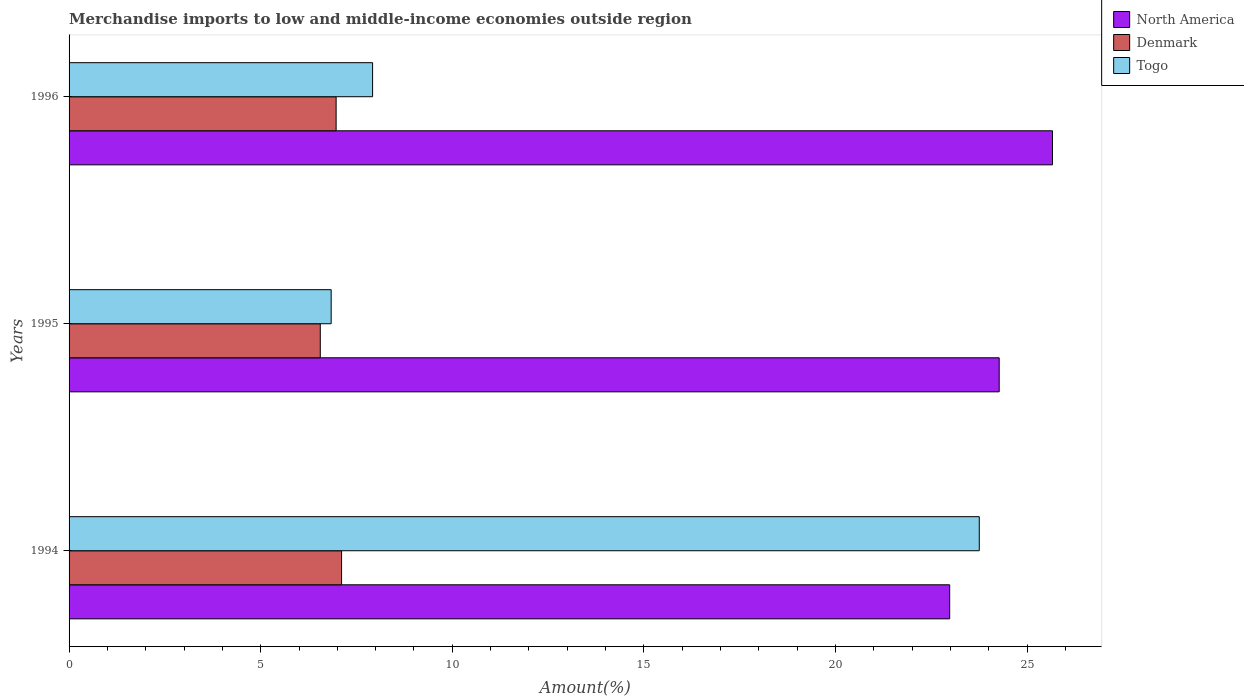How many groups of bars are there?
Your answer should be compact. 3. Are the number of bars per tick equal to the number of legend labels?
Offer a very short reply. Yes. Are the number of bars on each tick of the Y-axis equal?
Offer a terse response. Yes. How many bars are there on the 2nd tick from the bottom?
Provide a short and direct response. 3. In how many cases, is the number of bars for a given year not equal to the number of legend labels?
Keep it short and to the point. 0. What is the percentage of amount earned from merchandise imports in Denmark in 1996?
Your answer should be compact. 6.97. Across all years, what is the maximum percentage of amount earned from merchandise imports in North America?
Offer a very short reply. 25.66. Across all years, what is the minimum percentage of amount earned from merchandise imports in North America?
Give a very brief answer. 22.98. In which year was the percentage of amount earned from merchandise imports in Togo maximum?
Make the answer very short. 1994. In which year was the percentage of amount earned from merchandise imports in North America minimum?
Ensure brevity in your answer.  1994. What is the total percentage of amount earned from merchandise imports in North America in the graph?
Your answer should be very brief. 72.91. What is the difference between the percentage of amount earned from merchandise imports in Togo in 1994 and that in 1996?
Offer a very short reply. 15.83. What is the difference between the percentage of amount earned from merchandise imports in Togo in 1994 and the percentage of amount earned from merchandise imports in North America in 1995?
Ensure brevity in your answer.  -0.52. What is the average percentage of amount earned from merchandise imports in North America per year?
Offer a terse response. 24.3. In the year 1994, what is the difference between the percentage of amount earned from merchandise imports in Denmark and percentage of amount earned from merchandise imports in North America?
Provide a succinct answer. -15.87. What is the ratio of the percentage of amount earned from merchandise imports in Denmark in 1994 to that in 1995?
Give a very brief answer. 1.08. Is the difference between the percentage of amount earned from merchandise imports in Denmark in 1994 and 1996 greater than the difference between the percentage of amount earned from merchandise imports in North America in 1994 and 1996?
Offer a very short reply. Yes. What is the difference between the highest and the second highest percentage of amount earned from merchandise imports in Denmark?
Offer a terse response. 0.14. What is the difference between the highest and the lowest percentage of amount earned from merchandise imports in Togo?
Offer a very short reply. 16.91. What does the 2nd bar from the bottom in 1995 represents?
Give a very brief answer. Denmark. Are all the bars in the graph horizontal?
Your response must be concise. Yes. Are the values on the major ticks of X-axis written in scientific E-notation?
Ensure brevity in your answer.  No. Does the graph contain grids?
Ensure brevity in your answer.  No. How are the legend labels stacked?
Provide a short and direct response. Vertical. What is the title of the graph?
Keep it short and to the point. Merchandise imports to low and middle-income economies outside region. What is the label or title of the X-axis?
Offer a terse response. Amount(%). What is the label or title of the Y-axis?
Keep it short and to the point. Years. What is the Amount(%) in North America in 1994?
Make the answer very short. 22.98. What is the Amount(%) in Denmark in 1994?
Your answer should be very brief. 7.11. What is the Amount(%) in Togo in 1994?
Make the answer very short. 23.75. What is the Amount(%) in North America in 1995?
Offer a terse response. 24.27. What is the Amount(%) of Denmark in 1995?
Provide a short and direct response. 6.56. What is the Amount(%) of Togo in 1995?
Your answer should be compact. 6.84. What is the Amount(%) of North America in 1996?
Offer a terse response. 25.66. What is the Amount(%) of Denmark in 1996?
Offer a very short reply. 6.97. What is the Amount(%) of Togo in 1996?
Give a very brief answer. 7.92. Across all years, what is the maximum Amount(%) in North America?
Your answer should be compact. 25.66. Across all years, what is the maximum Amount(%) in Denmark?
Offer a very short reply. 7.11. Across all years, what is the maximum Amount(%) of Togo?
Provide a short and direct response. 23.75. Across all years, what is the minimum Amount(%) in North America?
Make the answer very short. 22.98. Across all years, what is the minimum Amount(%) of Denmark?
Offer a very short reply. 6.56. Across all years, what is the minimum Amount(%) of Togo?
Your answer should be compact. 6.84. What is the total Amount(%) in North America in the graph?
Keep it short and to the point. 72.91. What is the total Amount(%) in Denmark in the graph?
Give a very brief answer. 20.63. What is the total Amount(%) in Togo in the graph?
Offer a terse response. 38.51. What is the difference between the Amount(%) in North America in 1994 and that in 1995?
Ensure brevity in your answer.  -1.29. What is the difference between the Amount(%) of Denmark in 1994 and that in 1995?
Make the answer very short. 0.56. What is the difference between the Amount(%) of Togo in 1994 and that in 1995?
Give a very brief answer. 16.91. What is the difference between the Amount(%) of North America in 1994 and that in 1996?
Your answer should be very brief. -2.68. What is the difference between the Amount(%) in Denmark in 1994 and that in 1996?
Keep it short and to the point. 0.14. What is the difference between the Amount(%) of Togo in 1994 and that in 1996?
Provide a succinct answer. 15.83. What is the difference between the Amount(%) of North America in 1995 and that in 1996?
Your answer should be very brief. -1.39. What is the difference between the Amount(%) of Denmark in 1995 and that in 1996?
Your answer should be compact. -0.41. What is the difference between the Amount(%) of Togo in 1995 and that in 1996?
Your answer should be compact. -1.08. What is the difference between the Amount(%) in North America in 1994 and the Amount(%) in Denmark in 1995?
Ensure brevity in your answer.  16.42. What is the difference between the Amount(%) in North America in 1994 and the Amount(%) in Togo in 1995?
Make the answer very short. 16.14. What is the difference between the Amount(%) in Denmark in 1994 and the Amount(%) in Togo in 1995?
Your answer should be compact. 0.27. What is the difference between the Amount(%) in North America in 1994 and the Amount(%) in Denmark in 1996?
Keep it short and to the point. 16.01. What is the difference between the Amount(%) of North America in 1994 and the Amount(%) of Togo in 1996?
Offer a very short reply. 15.06. What is the difference between the Amount(%) of Denmark in 1994 and the Amount(%) of Togo in 1996?
Your response must be concise. -0.81. What is the difference between the Amount(%) in North America in 1995 and the Amount(%) in Denmark in 1996?
Ensure brevity in your answer.  17.3. What is the difference between the Amount(%) in North America in 1995 and the Amount(%) in Togo in 1996?
Provide a succinct answer. 16.35. What is the difference between the Amount(%) in Denmark in 1995 and the Amount(%) in Togo in 1996?
Your answer should be compact. -1.36. What is the average Amount(%) in North America per year?
Give a very brief answer. 24.3. What is the average Amount(%) in Denmark per year?
Keep it short and to the point. 6.88. What is the average Amount(%) of Togo per year?
Make the answer very short. 12.84. In the year 1994, what is the difference between the Amount(%) of North America and Amount(%) of Denmark?
Offer a terse response. 15.87. In the year 1994, what is the difference between the Amount(%) in North America and Amount(%) in Togo?
Offer a very short reply. -0.77. In the year 1994, what is the difference between the Amount(%) of Denmark and Amount(%) of Togo?
Your answer should be very brief. -16.64. In the year 1995, what is the difference between the Amount(%) in North America and Amount(%) in Denmark?
Make the answer very short. 17.72. In the year 1995, what is the difference between the Amount(%) of North America and Amount(%) of Togo?
Ensure brevity in your answer.  17.43. In the year 1995, what is the difference between the Amount(%) of Denmark and Amount(%) of Togo?
Provide a succinct answer. -0.28. In the year 1996, what is the difference between the Amount(%) of North America and Amount(%) of Denmark?
Ensure brevity in your answer.  18.69. In the year 1996, what is the difference between the Amount(%) of North America and Amount(%) of Togo?
Provide a short and direct response. 17.74. In the year 1996, what is the difference between the Amount(%) of Denmark and Amount(%) of Togo?
Ensure brevity in your answer.  -0.95. What is the ratio of the Amount(%) in North America in 1994 to that in 1995?
Give a very brief answer. 0.95. What is the ratio of the Amount(%) of Denmark in 1994 to that in 1995?
Ensure brevity in your answer.  1.08. What is the ratio of the Amount(%) in Togo in 1994 to that in 1995?
Your response must be concise. 3.47. What is the ratio of the Amount(%) in North America in 1994 to that in 1996?
Offer a terse response. 0.9. What is the ratio of the Amount(%) of Denmark in 1994 to that in 1996?
Your answer should be compact. 1.02. What is the ratio of the Amount(%) of Togo in 1994 to that in 1996?
Offer a terse response. 3. What is the ratio of the Amount(%) of North America in 1995 to that in 1996?
Make the answer very short. 0.95. What is the ratio of the Amount(%) of Denmark in 1995 to that in 1996?
Keep it short and to the point. 0.94. What is the ratio of the Amount(%) of Togo in 1995 to that in 1996?
Make the answer very short. 0.86. What is the difference between the highest and the second highest Amount(%) of North America?
Provide a succinct answer. 1.39. What is the difference between the highest and the second highest Amount(%) in Denmark?
Provide a succinct answer. 0.14. What is the difference between the highest and the second highest Amount(%) in Togo?
Provide a succinct answer. 15.83. What is the difference between the highest and the lowest Amount(%) of North America?
Offer a very short reply. 2.68. What is the difference between the highest and the lowest Amount(%) in Denmark?
Give a very brief answer. 0.56. What is the difference between the highest and the lowest Amount(%) in Togo?
Provide a succinct answer. 16.91. 